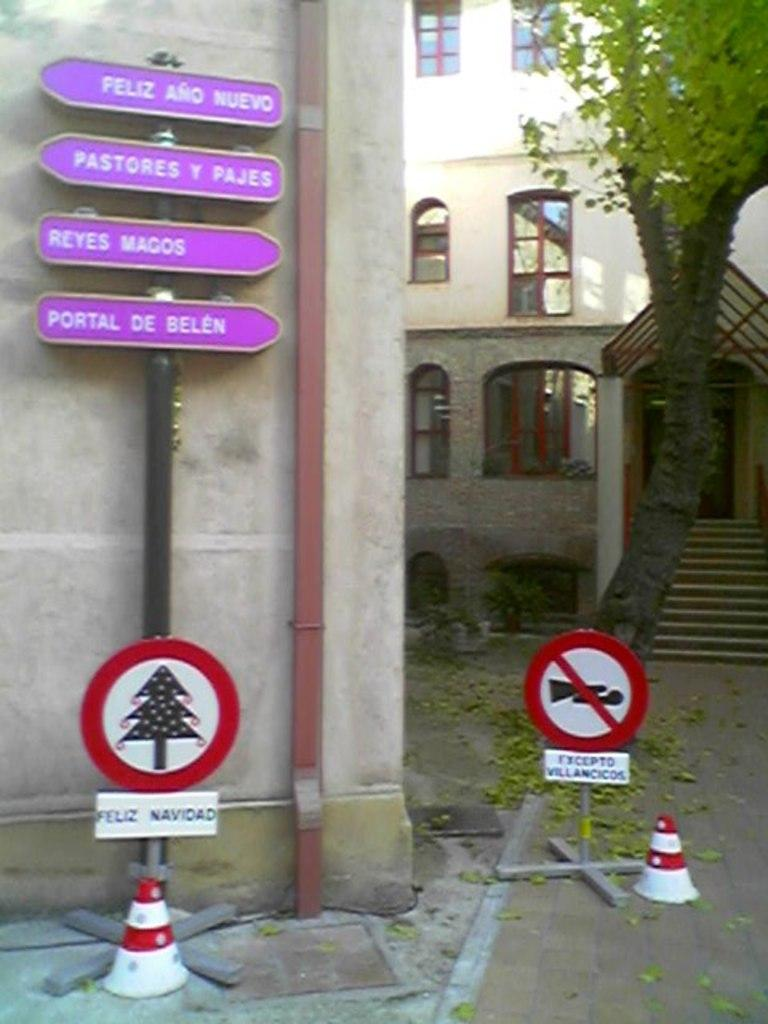<image>
Share a concise interpretation of the image provided. The bottom purple sign says Portal de Belen. 